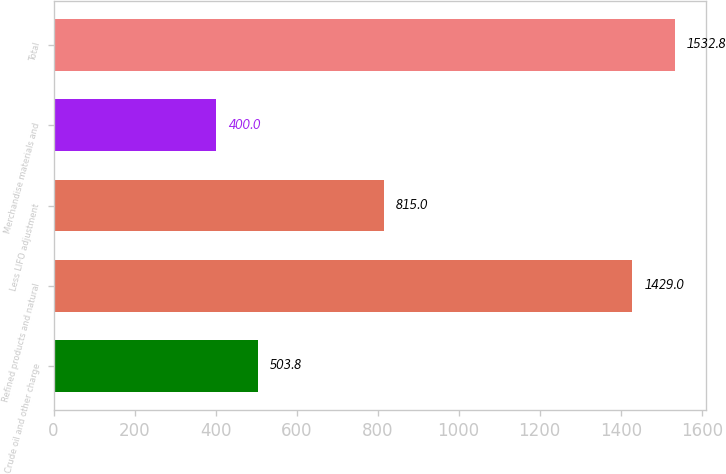Convert chart. <chart><loc_0><loc_0><loc_500><loc_500><bar_chart><fcel>Crude oil and other charge<fcel>Refined products and natural<fcel>Less LIFO adjustment<fcel>Merchandise materials and<fcel>Total<nl><fcel>503.8<fcel>1429<fcel>815<fcel>400<fcel>1532.8<nl></chart> 